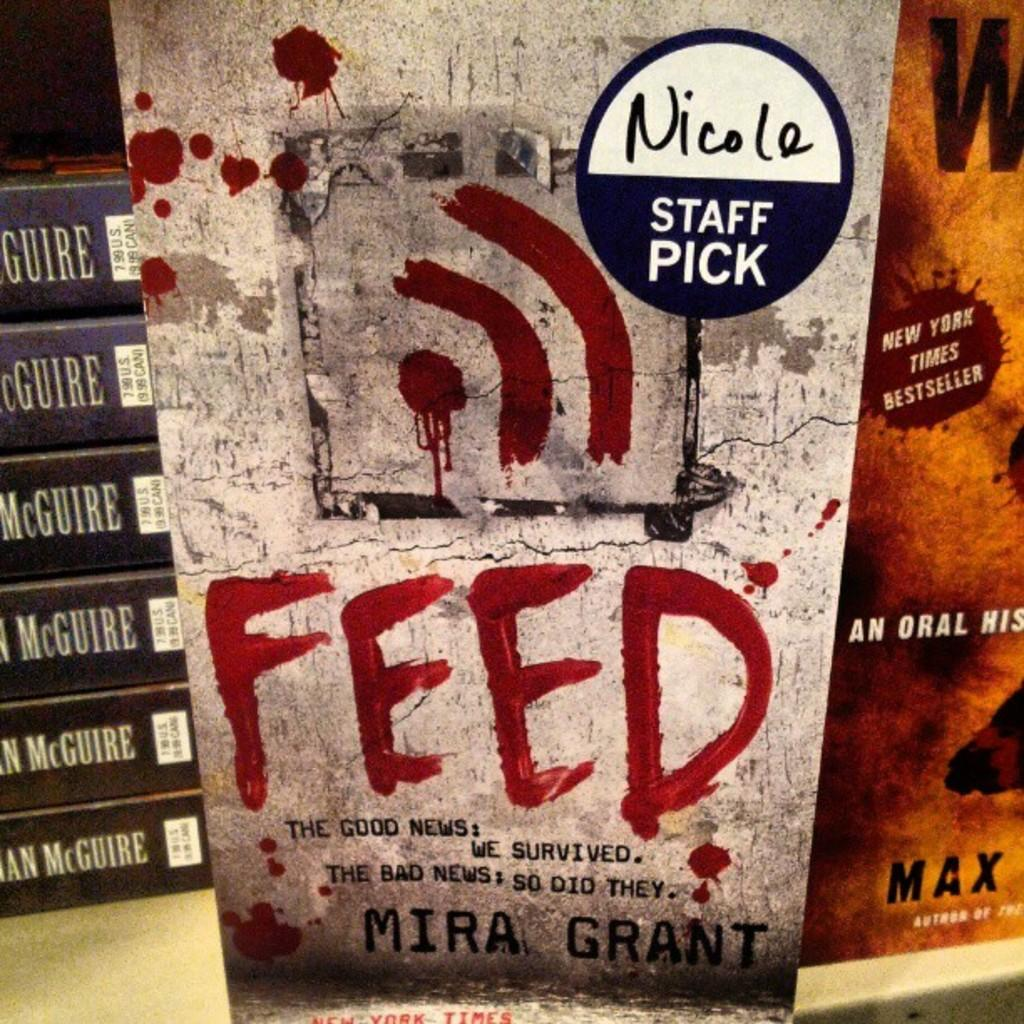<image>
Describe the image concisely. the book cover of feed by mira grant which is the staff pick 